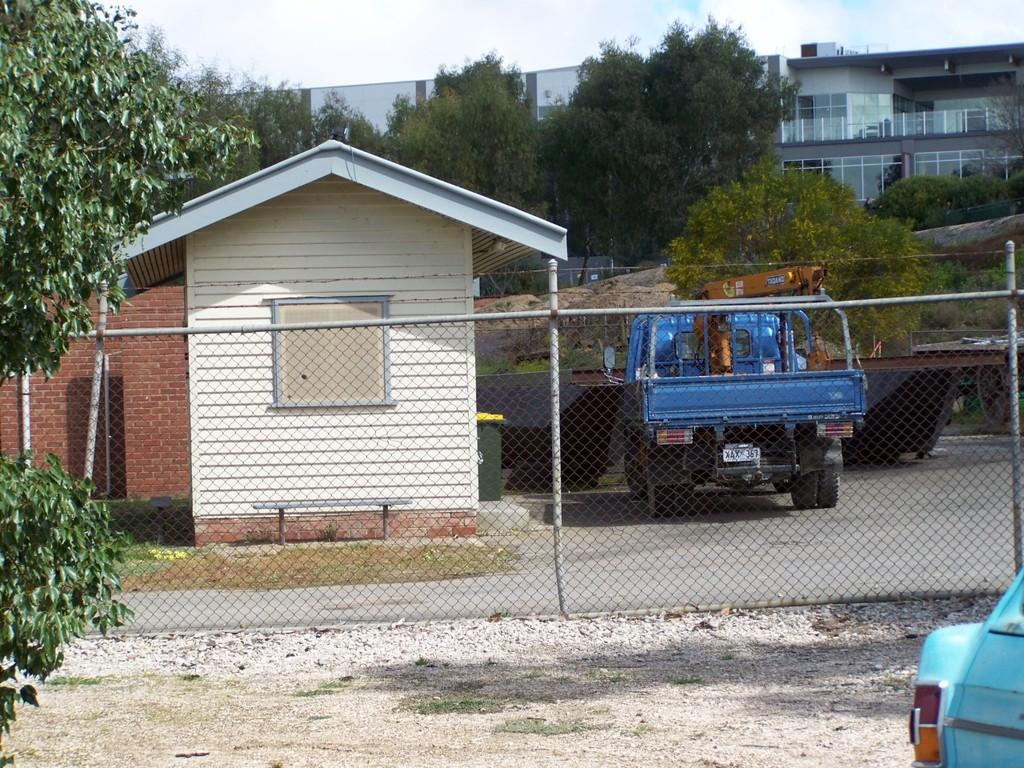What type of structure is in the image? There is a building in the image. Can you describe any specific features of the building? There is a window in the image. What can be seen on the road in front of the building? Vehicles are visible on the road. What is in front of the building to provide security or separation? There is a fencing in front of the building. What type of vegetation is near the fencing? Trees are present near the fencing. What is the color of the sky in the image? The sky is blue and white in color. What type of rings can be seen on the market in the image? There is no market or rings present in the image. What invention is being demonstrated in the image? There is no invention being demonstrated in the image. 